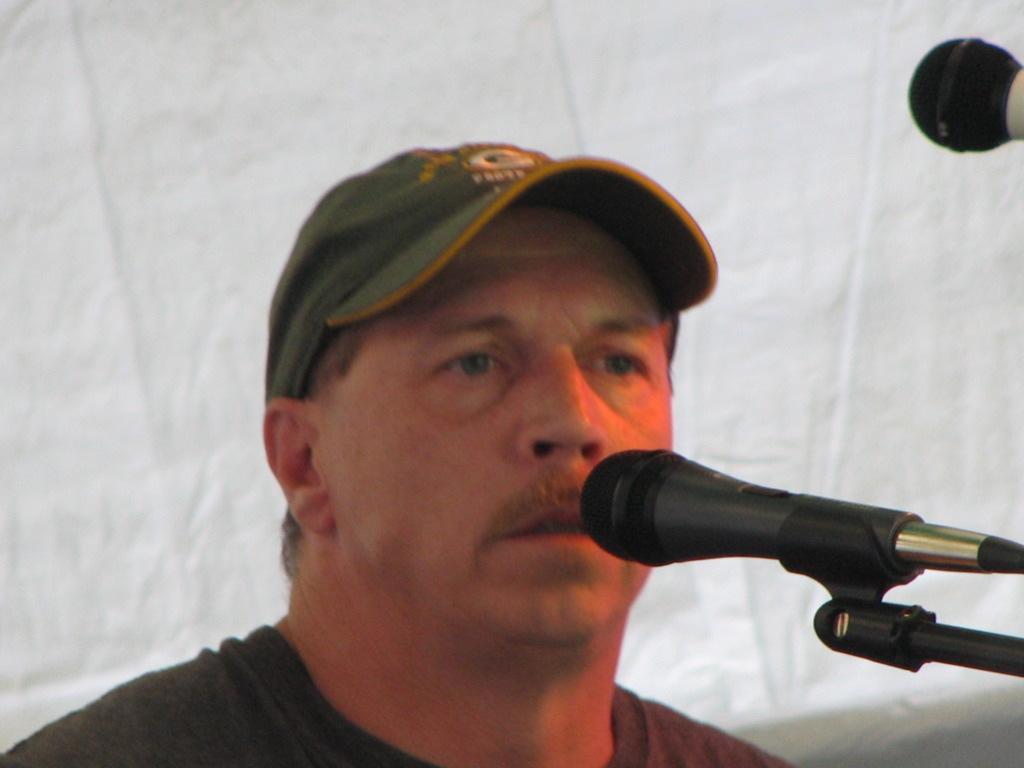How would you summarize this image in a sentence or two? In the image there is a man, he is wearing a hat and there are two mics on the right side of the image. 